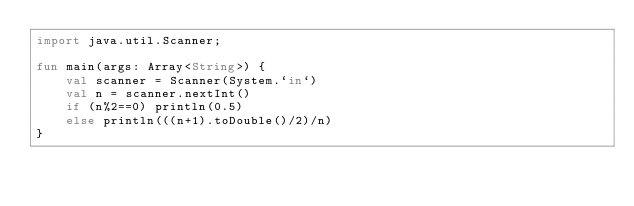<code> <loc_0><loc_0><loc_500><loc_500><_Kotlin_>import java.util.Scanner;

fun main(args: Array<String>) {
	val scanner = Scanner(System.`in`)
	val n = scanner.nextInt()
	if (n%2==0) println(0.5)
	else println(((n+1).toDouble()/2)/n)
}</code> 